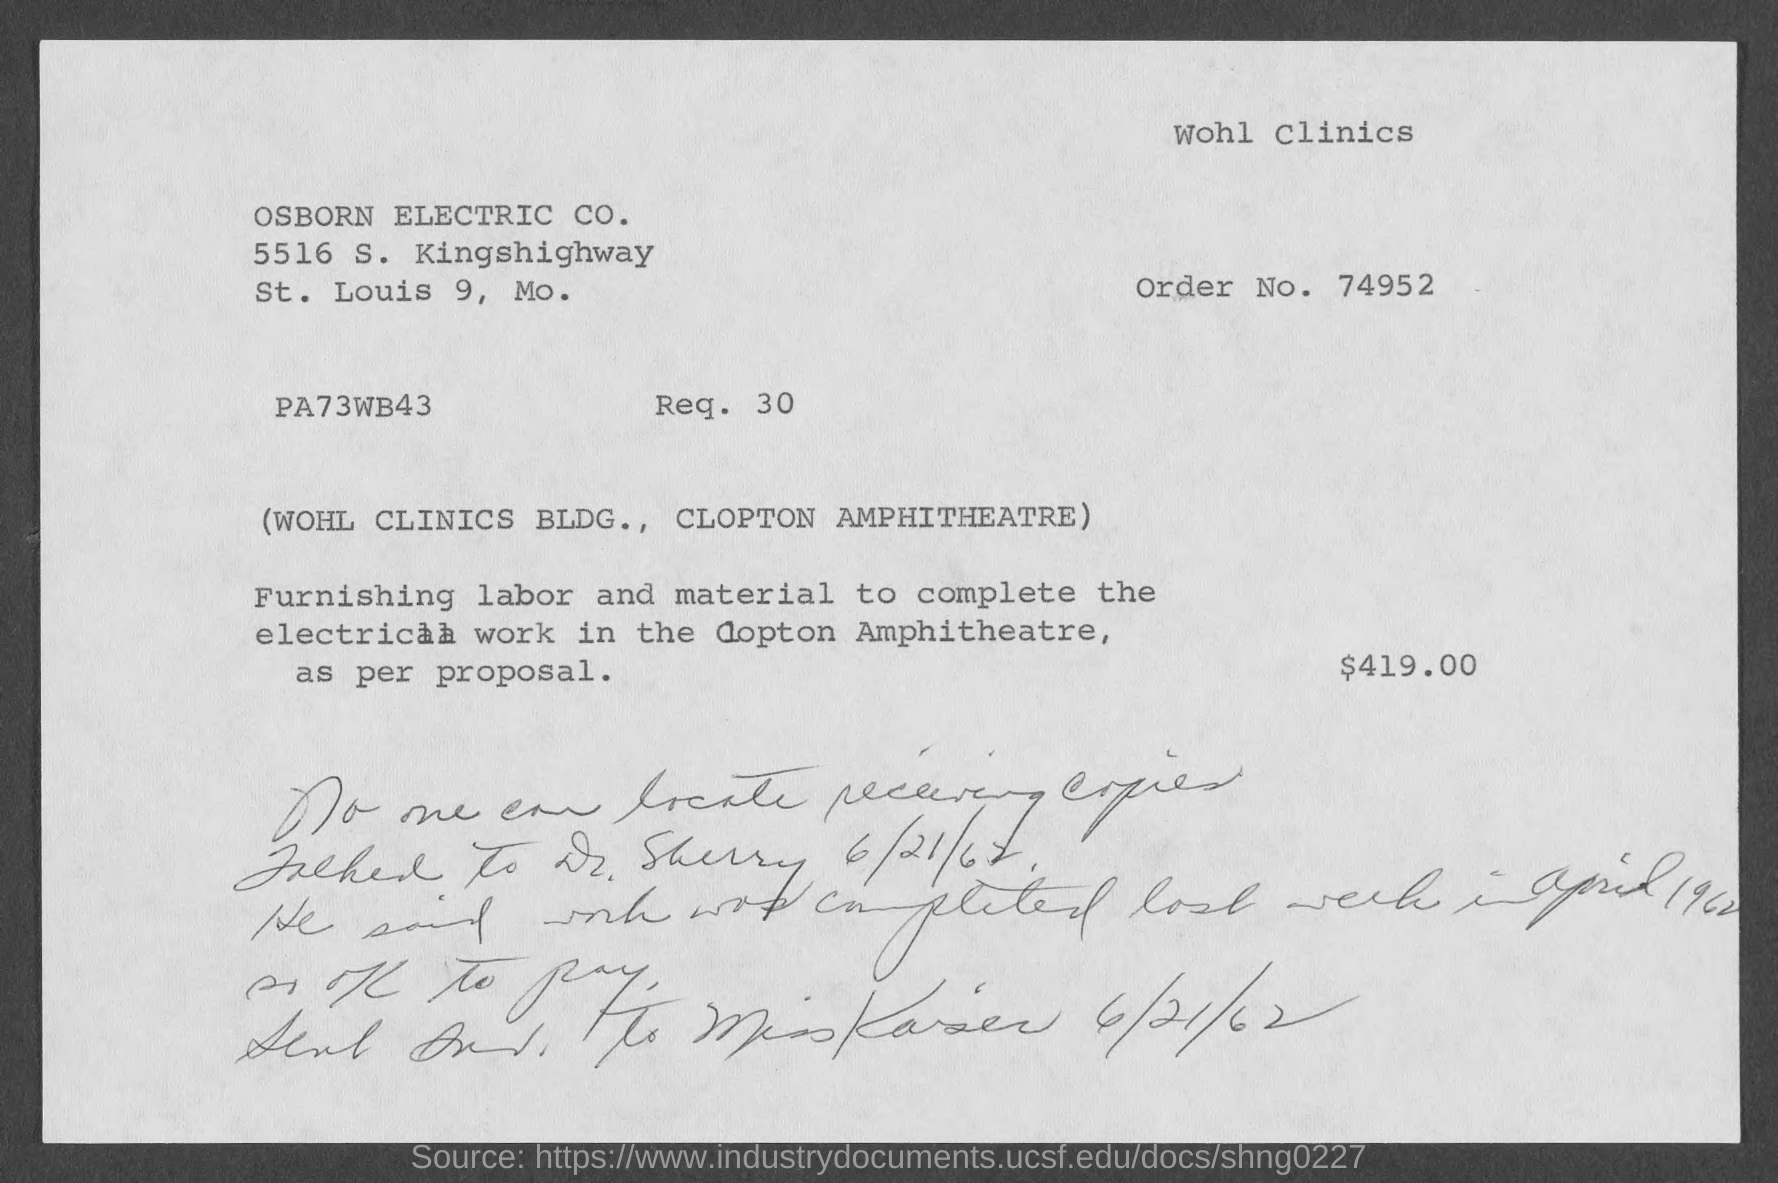What is the order no.?
Provide a succinct answer. 74952. What is the street address of osborn electric co. ?
Your answer should be very brief. 5516 S. Kingshighway. 